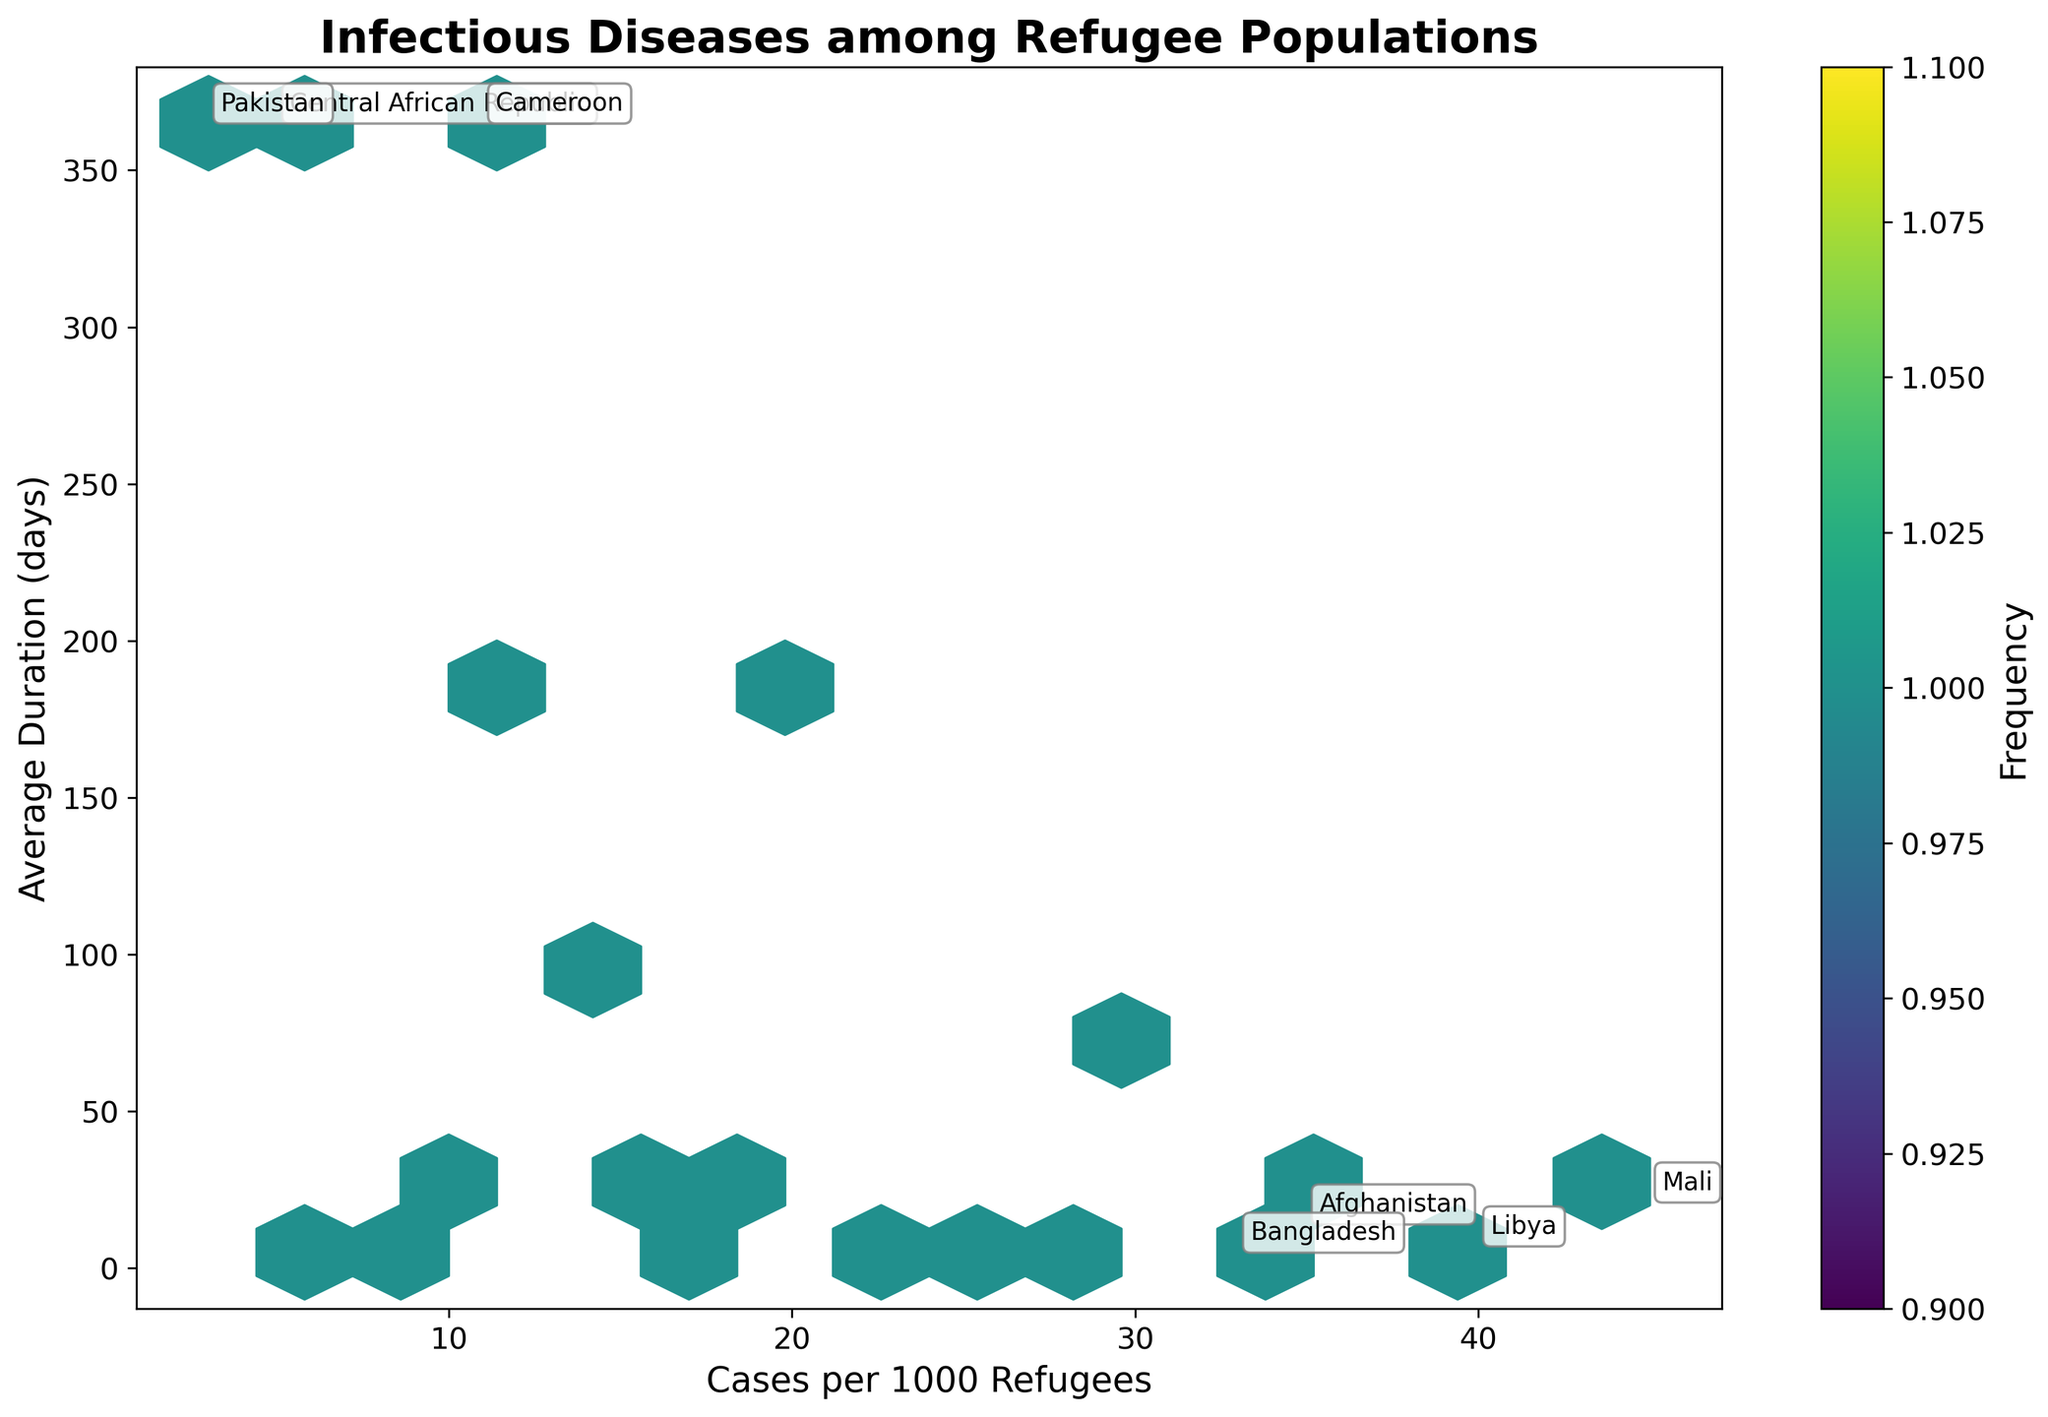What's the title of the figure? The title of the figure is displayed at the top, indicating the overall subject of the plot. It reads, "Infectious Diseases among Refugee Populations".
Answer: Infectious Diseases among Refugee Populations How many cases per 1000 refugees does Libya have? By referring to the hexbin plot, we can identify the annotated point with "Libya". This point corresponds to a value of 40 cases per 1000 refugees.
Answer: 40 Which disease has the longest average duration? To find the longest average duration, look for the highest point on the y-axis. The point for Trachoma (with Ethiopia) reaches a duration of 180 days.
Answer: Trachoma Which country has both a high number of cases per 1000 refugees and a chronic disease duration? Find countries annotated in the plot that fall into or near the high x-axis values and the 365 days mark. "Central African Republic" is annotated and positioned at 5 cases per 1000 refugees and 365 days for HIV/AIDS.
Answer: Central African Republic What's the frequency color for diseases that have around 10 cases per 1000 refugees and an average duration of around 14 days? The color of the hexagons in this area (approximately 10 cases per 1000 and 14 days) can be observed. They appear to be colored in light green tones, indicating a moderate frequency.
Answer: Light green Which diseases have a very short average duration (less than 10 days) but more than 20 cases per 1000 refugees? Look for points with a low y-axis value (less than 10 days) and high x-axis value (more than 20 cases per 1000). The diseases meeting these criteria are Cholera (from South Sudan) and Influenza (from Libya).
Answer: Cholera, Influenza How does the duration of dengue fever compare to other diseases that have over 20 cases per 1000 refugees? Identify the duration of dengue fever on the y-axis and compare it to the other points with values of more than 20 cases per 1000 refugees. Dengue Fever (7 days) has a shorter duration compared to Schistosomiasis (60 days) but similar to Cholera (7 days) and Influenza (7 days).
Answer: Shorter or similar Which countries have infectious diseases with average durations of around 14 days? Look for points along the y-axis corresponding to around 14 days. Annotated points suggest the countries are Afghanistan (Malaria), Yemen (Diphtheria), and Nigeria (Meningitis).
Answer: Afghanistan, Yemen, Nigeria What's the range of average durations for diseases with fewer than 10 cases per 1000 refugees? Identify points on the plot with fewer than 10 cases per 1000 refugees and observe their y-axis values for duration. Countries within this range are the Central African Republic (365 days) and Sudan (10 days), showing a range of 10 to 365 days.
Answer: 10 to 365 days Which country of origin has the highest number of cases per 1000 refugees? Identify the point on the x-axis with the highest value. The annotation indicates that Mali has 45 cases per 1000 refugees (Scabies).
Answer: Mali 